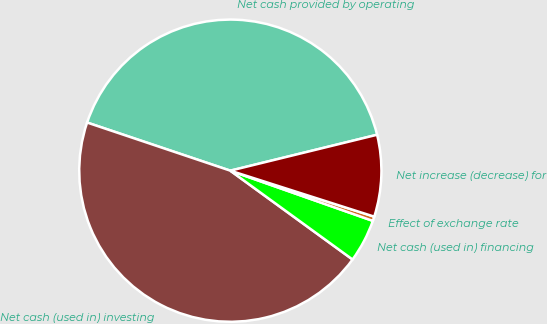Convert chart to OTSL. <chart><loc_0><loc_0><loc_500><loc_500><pie_chart><fcel>Net cash provided by operating<fcel>Net cash (used in) investing<fcel>Net cash (used in) financing<fcel>Effect of exchange rate<fcel>Net increase (decrease) for<nl><fcel>41.02%<fcel>45.16%<fcel>4.61%<fcel>0.47%<fcel>8.74%<nl></chart> 